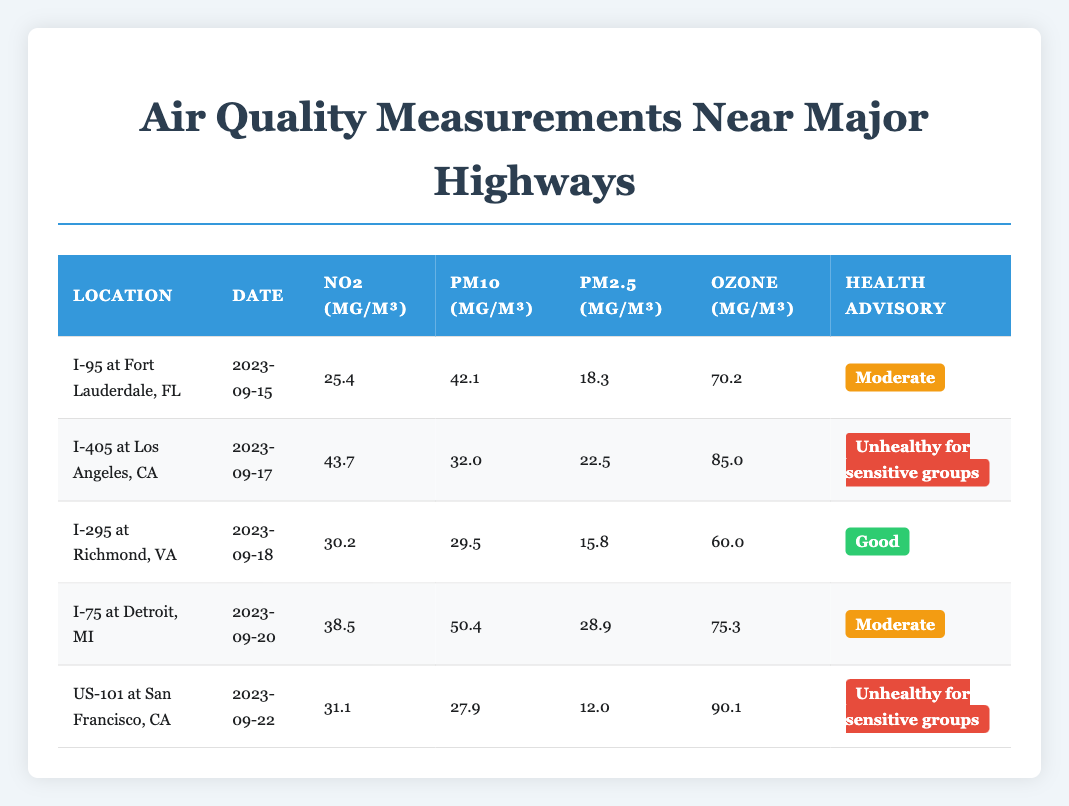What was the highest recorded NO2 level? To find the highest recorded NO2 level, I need to check the NO2 values across all locations. The NO2 levels are as follows: I-95 at Fort Lauderdale (25.4), I-405 at Los Angeles (43.7), I-295 at Richmond (30.2), I-75 at Detroit (38.5), and US-101 at San Francisco (31.1). The highest value is 43.7 at I-405 in Los Angeles.
Answer: 43.7 What is the average PM10 measurement across all locations? To calculate the average PM10 measurement, I will first sum all the PM10 values: 42.1 (I-95) + 32.0 (I-405) + 29.5 (I-295) + 50.4 (I-75) + 27.9 (US-101) = 181.9. There are 5 measurements, so the average is 181.9 / 5 = 36.38.
Answer: 36.38 Is the ozone level at I-295 considered good? The ozone level recorded at I-295 is 60.0 µg/m³. According to the health advisories, this measurement falls under the "Good" designation, indicating it is safe.
Answer: Yes Which location has the worst health advisory? To determine which location has the worst health advisory, I can compare the health advisory levels. The health advisories are: I-95 (Moderate), I-405 (Unhealthy for sensitive groups), I-295 (Good), I-75 (Moderate), and US-101 (Unhealthy for sensitive groups). The worst are "Unhealthy for sensitive groups," which occurs at two locations: I-405 and US-101.
Answer: I-405 and US-101 How does the PM2.5 level at I-75 compare to the average PM2.5 level? First, I calculate the average PM2.5 level by summing the values: 18.3 (I-95) + 22.5 (I-405) + 15.8 (I-295) + 28.9 (I-75) + 12.0 (US-101) = 97.5. The average PM2.5 level is 97.5 / 5 = 19.5. At I-75, the PM2.5 level is 28.9, which is higher than the average of 19.5.
Answer: Higher than average What was the ozone measurement for the location with the best health advisory? I need to identify the location with the best health advisory, which is I-295 (Good). The ozone measurement there is 60.0 µg/m³.
Answer: 60.0 